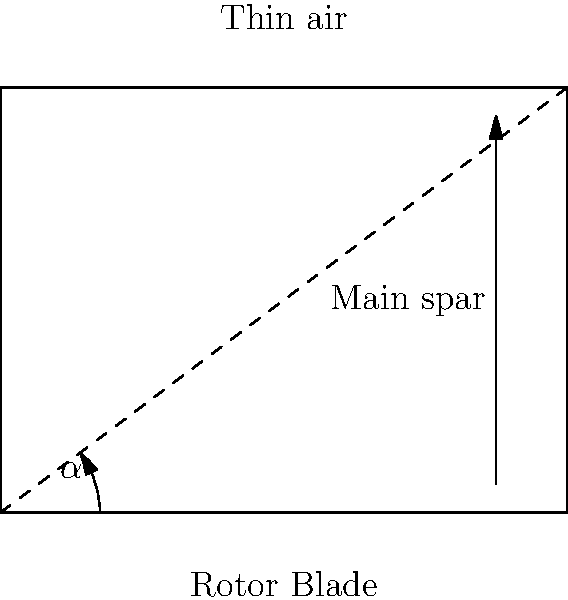The diagram shows a cross-section of a helicopter rotor blade designed for thin air conditions. Given that the angle of attack $\alpha$ is crucial for optimal performance in low-density atmospheres, how would you modify the blade design to maintain lift efficiency while considering the reduced air density? Explain the aerodynamic principles involved and suggest at least two specific design changes. To optimize the helicopter rotor blade design for thin air conditions, we need to consider several aerodynamic principles and make appropriate design modifications:

1. Lift in thin air:
   - In low-density atmospheres, the air molecules are fewer, reducing the lift generated by the rotor blades.
   - Lift is proportional to air density: $L = \frac{1}{2} \rho v^2 C_L A$, where $\rho$ is air density, $v$ is velocity, $C_L$ is the lift coefficient, and $A$ is the blade area.

2. Angle of attack ($\alpha$) adjustment:
   - Increase the angle of attack to compensate for reduced lift in thin air.
   - This increases the lift coefficient $C_L$, but care must be taken to avoid stall conditions.

3. Blade area modification:
   - Increase the blade area (A) to generate more lift.
   - This can be achieved by increasing the blade chord length or overall rotor diameter.

4. Blade profile optimization:
   - Use a more efficient airfoil design, such as a high-lift, low-drag profile.
   - Consider asymmetric airfoils with a larger camber to increase lift generation.

5. Blade tip design:
   - Implement swept tip designs or winglets to reduce induced drag and improve efficiency.

6. Structural considerations:
   - Use lightweight materials to reduce overall weight while maintaining structural integrity.
   - This allows for larger blades without significantly increasing the rotor's moment of inertia.

Specific design changes:

a. Increase blade chord length by 15-20% to enlarge the blade area, enhancing lift generation.
b. Implement a high-lift airfoil profile with increased camber (e.g., 5-7% increase) to improve lift coefficient.
c. Add swept tips or winglets to reduce induced drag and increase overall rotor efficiency.

These modifications aim to maintain lift efficiency in thin air conditions by compensating for the reduced air density through increased lift generation and improved aerodynamic performance.
Answer: Increase blade area and use high-lift airfoil profile with larger camber. 